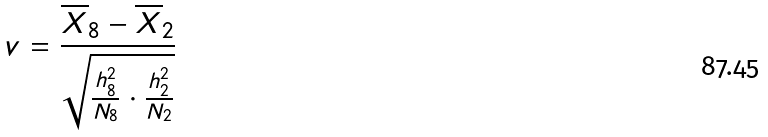Convert formula to latex. <formula><loc_0><loc_0><loc_500><loc_500>v = \frac { \overline { X } _ { 8 } - \overline { X } _ { 2 } } { \sqrt { \frac { h _ { 8 } ^ { 2 } } { N _ { 8 } } \cdot \frac { h _ { 2 } ^ { 2 } } { N _ { 2 } } } }</formula> 